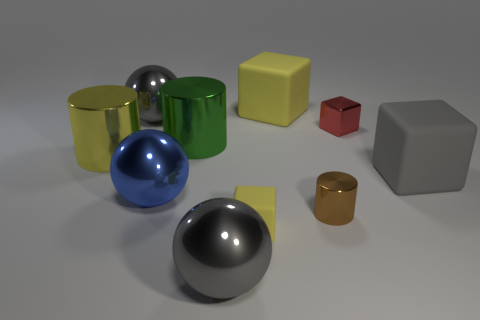How many objects are gray objects or big blue metallic spheres?
Make the answer very short. 4. What is the size of the object that is both on the right side of the tiny brown metallic cylinder and behind the green thing?
Keep it short and to the point. Small. Are there fewer gray shiny objects in front of the small shiny cylinder than purple shiny objects?
Make the answer very short. No. There is a small red object that is the same material as the small brown thing; what is its shape?
Ensure brevity in your answer.  Cube. Does the big gray thing behind the big yellow metallic thing have the same shape as the large gray shiny object that is in front of the red object?
Keep it short and to the point. Yes. Is the number of red blocks to the left of the tiny cylinder less than the number of large yellow objects that are in front of the red metallic object?
Keep it short and to the point. Yes. There is another rubber thing that is the same color as the small matte object; what shape is it?
Provide a short and direct response. Cube. How many red shiny cubes are the same size as the yellow shiny object?
Make the answer very short. 0. Does the yellow thing behind the small red cube have the same material as the tiny yellow block?
Your answer should be very brief. Yes. Are there any blue objects?
Offer a very short reply. Yes. 